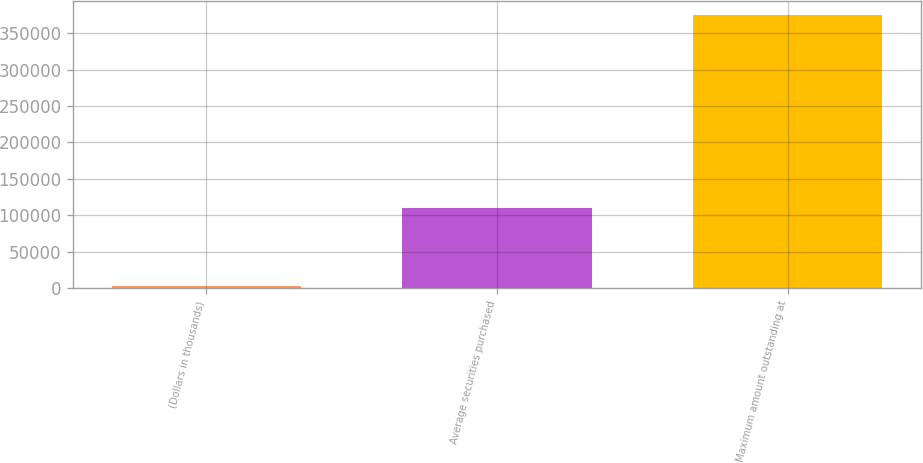Convert chart. <chart><loc_0><loc_0><loc_500><loc_500><bar_chart><fcel>(Dollars in thousands)<fcel>Average securities purchased<fcel>Maximum amount outstanding at<nl><fcel>2011<fcel>110291<fcel>375236<nl></chart> 